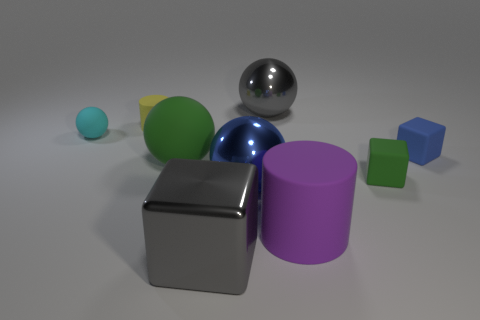The big thing that is on the right side of the large blue shiny object and in front of the blue rubber block has what shape?
Your response must be concise. Cylinder. Does the purple matte object have the same size as the green rubber ball?
Make the answer very short. Yes. There is a purple cylinder; how many small cyan things are to the right of it?
Provide a succinct answer. 0. Are there an equal number of small matte cylinders to the right of the green ball and large green matte balls in front of the tiny green cube?
Provide a short and direct response. Yes. There is a small matte thing that is on the right side of the tiny green cube; does it have the same shape as the cyan rubber thing?
Provide a succinct answer. No. Is there anything else that has the same material as the tiny blue thing?
Your answer should be very brief. Yes. Do the cyan matte sphere and the matte cylinder that is to the right of the big rubber sphere have the same size?
Ensure brevity in your answer.  No. How many other objects are there of the same color as the large cylinder?
Offer a very short reply. 0. There is a cyan sphere; are there any small rubber cubes on the left side of it?
Your response must be concise. No. What number of things are small yellow matte balls or cubes that are behind the large green matte ball?
Give a very brief answer. 1. 